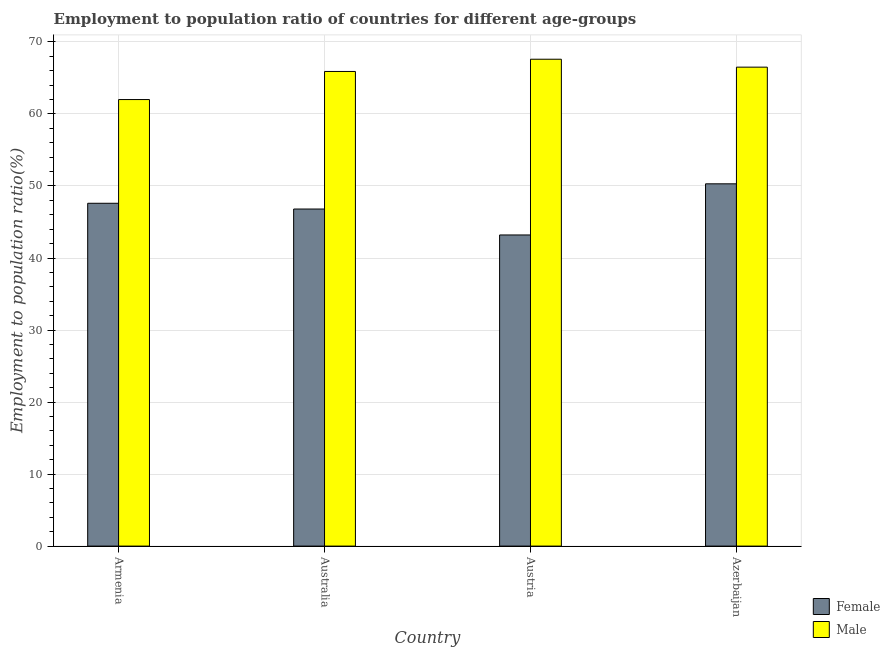How many different coloured bars are there?
Offer a very short reply. 2. How many groups of bars are there?
Provide a short and direct response. 4. Are the number of bars on each tick of the X-axis equal?
Offer a terse response. Yes. How many bars are there on the 1st tick from the left?
Provide a short and direct response. 2. How many bars are there on the 4th tick from the right?
Your answer should be very brief. 2. What is the label of the 2nd group of bars from the left?
Make the answer very short. Australia. What is the employment to population ratio(female) in Armenia?
Provide a short and direct response. 47.6. Across all countries, what is the maximum employment to population ratio(female)?
Provide a short and direct response. 50.3. Across all countries, what is the minimum employment to population ratio(female)?
Your response must be concise. 43.2. In which country was the employment to population ratio(female) maximum?
Provide a short and direct response. Azerbaijan. In which country was the employment to population ratio(female) minimum?
Offer a terse response. Austria. What is the total employment to population ratio(male) in the graph?
Provide a succinct answer. 262. What is the difference between the employment to population ratio(female) in Armenia and that in Australia?
Provide a succinct answer. 0.8. What is the difference between the employment to population ratio(male) in Azerbaijan and the employment to population ratio(female) in Armenia?
Your answer should be compact. 18.9. What is the average employment to population ratio(male) per country?
Keep it short and to the point. 65.5. What is the difference between the employment to population ratio(female) and employment to population ratio(male) in Armenia?
Provide a short and direct response. -14.4. What is the ratio of the employment to population ratio(female) in Armenia to that in Austria?
Keep it short and to the point. 1.1. What is the difference between the highest and the second highest employment to population ratio(male)?
Provide a succinct answer. 1.1. What is the difference between the highest and the lowest employment to population ratio(male)?
Your response must be concise. 5.6. In how many countries, is the employment to population ratio(male) greater than the average employment to population ratio(male) taken over all countries?
Offer a terse response. 3. What does the 2nd bar from the left in Armenia represents?
Your response must be concise. Male. What does the 1st bar from the right in Australia represents?
Provide a succinct answer. Male. How many bars are there?
Offer a very short reply. 8. Are all the bars in the graph horizontal?
Keep it short and to the point. No. Are the values on the major ticks of Y-axis written in scientific E-notation?
Provide a succinct answer. No. Does the graph contain grids?
Offer a very short reply. Yes. Where does the legend appear in the graph?
Offer a terse response. Bottom right. How are the legend labels stacked?
Provide a succinct answer. Vertical. What is the title of the graph?
Your answer should be very brief. Employment to population ratio of countries for different age-groups. Does "Merchandise exports" appear as one of the legend labels in the graph?
Your answer should be very brief. No. What is the label or title of the X-axis?
Your answer should be compact. Country. What is the Employment to population ratio(%) of Female in Armenia?
Offer a very short reply. 47.6. What is the Employment to population ratio(%) in Female in Australia?
Your response must be concise. 46.8. What is the Employment to population ratio(%) of Male in Australia?
Keep it short and to the point. 65.9. What is the Employment to population ratio(%) of Female in Austria?
Offer a very short reply. 43.2. What is the Employment to population ratio(%) in Male in Austria?
Make the answer very short. 67.6. What is the Employment to population ratio(%) of Female in Azerbaijan?
Your answer should be compact. 50.3. What is the Employment to population ratio(%) in Male in Azerbaijan?
Provide a short and direct response. 66.5. Across all countries, what is the maximum Employment to population ratio(%) of Female?
Your answer should be compact. 50.3. Across all countries, what is the maximum Employment to population ratio(%) of Male?
Provide a short and direct response. 67.6. Across all countries, what is the minimum Employment to population ratio(%) in Female?
Your response must be concise. 43.2. What is the total Employment to population ratio(%) in Female in the graph?
Keep it short and to the point. 187.9. What is the total Employment to population ratio(%) of Male in the graph?
Offer a very short reply. 262. What is the difference between the Employment to population ratio(%) of Female in Armenia and that in Australia?
Your answer should be compact. 0.8. What is the difference between the Employment to population ratio(%) in Male in Armenia and that in Australia?
Offer a very short reply. -3.9. What is the difference between the Employment to population ratio(%) of Female in Armenia and that in Austria?
Offer a terse response. 4.4. What is the difference between the Employment to population ratio(%) of Male in Armenia and that in Austria?
Make the answer very short. -5.6. What is the difference between the Employment to population ratio(%) in Female in Armenia and that in Azerbaijan?
Keep it short and to the point. -2.7. What is the difference between the Employment to population ratio(%) of Female in Australia and that in Austria?
Offer a very short reply. 3.6. What is the difference between the Employment to population ratio(%) of Male in Austria and that in Azerbaijan?
Keep it short and to the point. 1.1. What is the difference between the Employment to population ratio(%) of Female in Armenia and the Employment to population ratio(%) of Male in Australia?
Keep it short and to the point. -18.3. What is the difference between the Employment to population ratio(%) in Female in Armenia and the Employment to population ratio(%) in Male in Azerbaijan?
Give a very brief answer. -18.9. What is the difference between the Employment to population ratio(%) of Female in Australia and the Employment to population ratio(%) of Male in Austria?
Your answer should be very brief. -20.8. What is the difference between the Employment to population ratio(%) of Female in Australia and the Employment to population ratio(%) of Male in Azerbaijan?
Make the answer very short. -19.7. What is the difference between the Employment to population ratio(%) in Female in Austria and the Employment to population ratio(%) in Male in Azerbaijan?
Provide a succinct answer. -23.3. What is the average Employment to population ratio(%) of Female per country?
Make the answer very short. 46.98. What is the average Employment to population ratio(%) in Male per country?
Provide a short and direct response. 65.5. What is the difference between the Employment to population ratio(%) in Female and Employment to population ratio(%) in Male in Armenia?
Provide a short and direct response. -14.4. What is the difference between the Employment to population ratio(%) of Female and Employment to population ratio(%) of Male in Australia?
Keep it short and to the point. -19.1. What is the difference between the Employment to population ratio(%) of Female and Employment to population ratio(%) of Male in Austria?
Your answer should be compact. -24.4. What is the difference between the Employment to population ratio(%) in Female and Employment to population ratio(%) in Male in Azerbaijan?
Keep it short and to the point. -16.2. What is the ratio of the Employment to population ratio(%) in Female in Armenia to that in Australia?
Offer a terse response. 1.02. What is the ratio of the Employment to population ratio(%) in Male in Armenia to that in Australia?
Provide a succinct answer. 0.94. What is the ratio of the Employment to population ratio(%) in Female in Armenia to that in Austria?
Provide a short and direct response. 1.1. What is the ratio of the Employment to population ratio(%) in Male in Armenia to that in Austria?
Provide a succinct answer. 0.92. What is the ratio of the Employment to population ratio(%) in Female in Armenia to that in Azerbaijan?
Your response must be concise. 0.95. What is the ratio of the Employment to population ratio(%) of Male in Armenia to that in Azerbaijan?
Your answer should be compact. 0.93. What is the ratio of the Employment to population ratio(%) in Female in Australia to that in Austria?
Offer a very short reply. 1.08. What is the ratio of the Employment to population ratio(%) in Male in Australia to that in Austria?
Make the answer very short. 0.97. What is the ratio of the Employment to population ratio(%) of Female in Australia to that in Azerbaijan?
Provide a succinct answer. 0.93. What is the ratio of the Employment to population ratio(%) of Male in Australia to that in Azerbaijan?
Offer a terse response. 0.99. What is the ratio of the Employment to population ratio(%) in Female in Austria to that in Azerbaijan?
Your answer should be very brief. 0.86. What is the ratio of the Employment to population ratio(%) in Male in Austria to that in Azerbaijan?
Your answer should be very brief. 1.02. What is the difference between the highest and the lowest Employment to population ratio(%) of Female?
Provide a succinct answer. 7.1. 